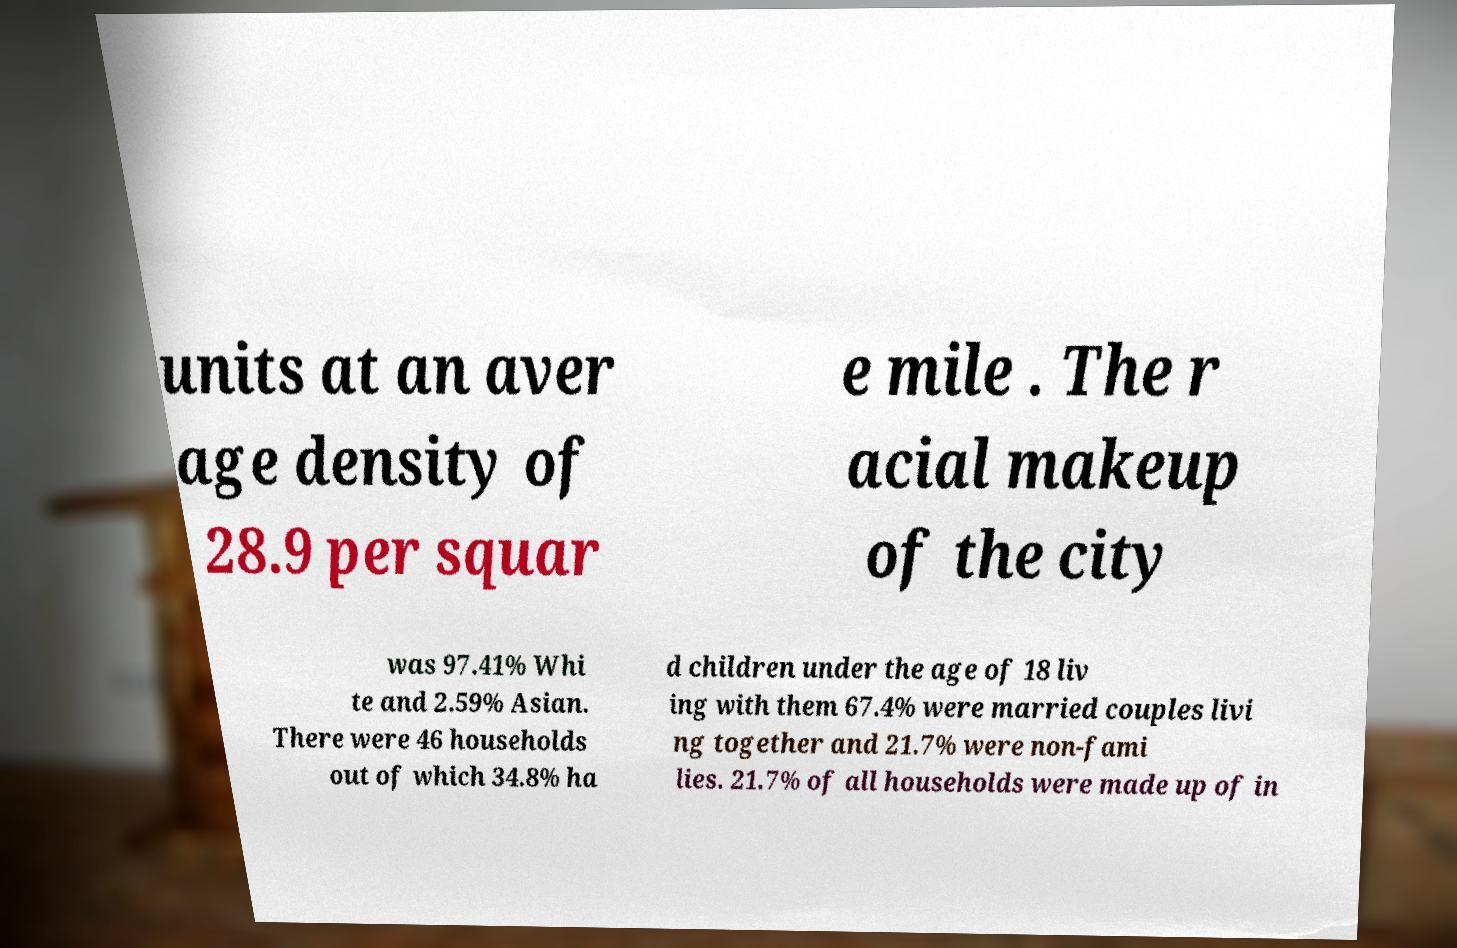Could you assist in decoding the text presented in this image and type it out clearly? units at an aver age density of 28.9 per squar e mile . The r acial makeup of the city was 97.41% Whi te and 2.59% Asian. There were 46 households out of which 34.8% ha d children under the age of 18 liv ing with them 67.4% were married couples livi ng together and 21.7% were non-fami lies. 21.7% of all households were made up of in 